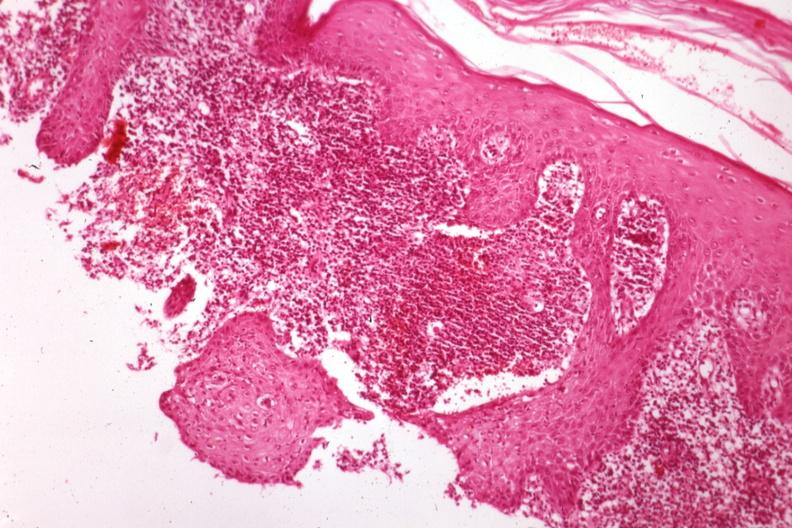what is present?
Answer the question using a single word or phrase. Sporotrichosis 